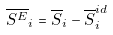<formula> <loc_0><loc_0><loc_500><loc_500>\overline { S ^ { E } } _ { i } = \overline { S } _ { i } - \overline { S } _ { i } ^ { i d }</formula> 